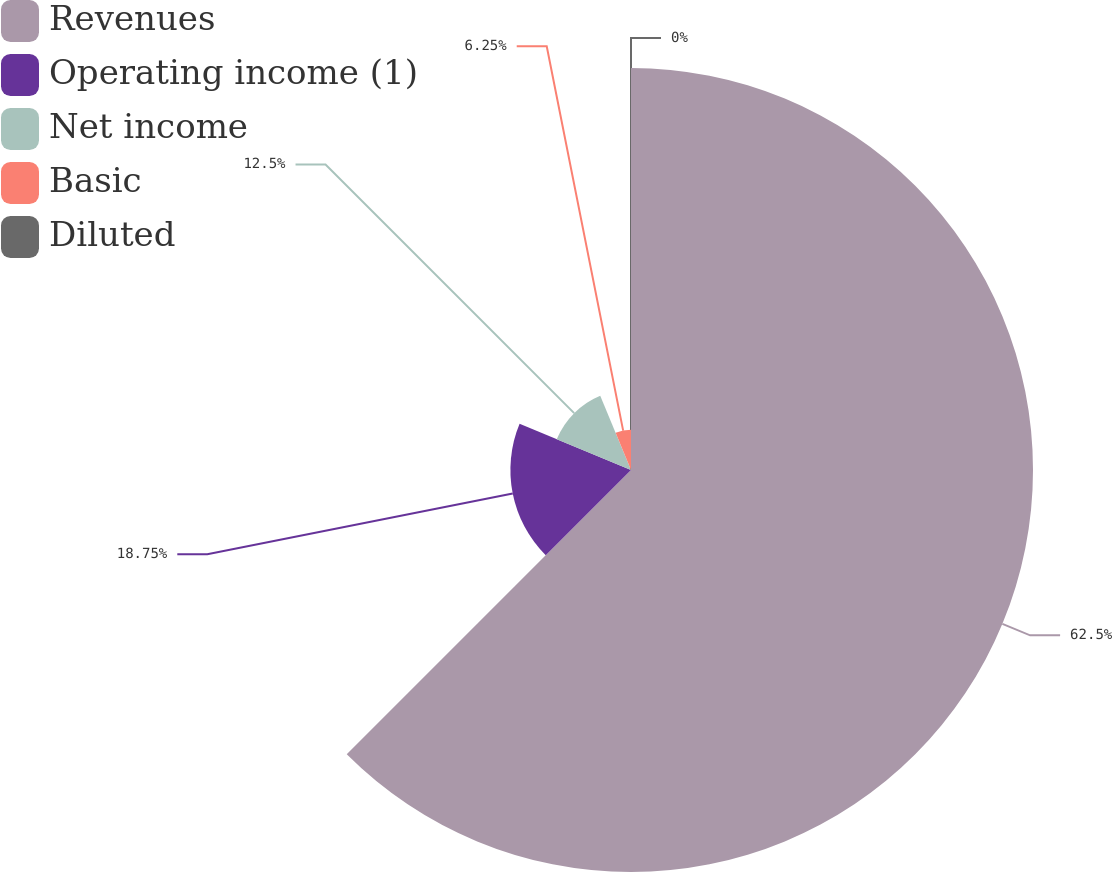<chart> <loc_0><loc_0><loc_500><loc_500><pie_chart><fcel>Revenues<fcel>Operating income (1)<fcel>Net income<fcel>Basic<fcel>Diluted<nl><fcel>62.5%<fcel>18.75%<fcel>12.5%<fcel>6.25%<fcel>0.0%<nl></chart> 